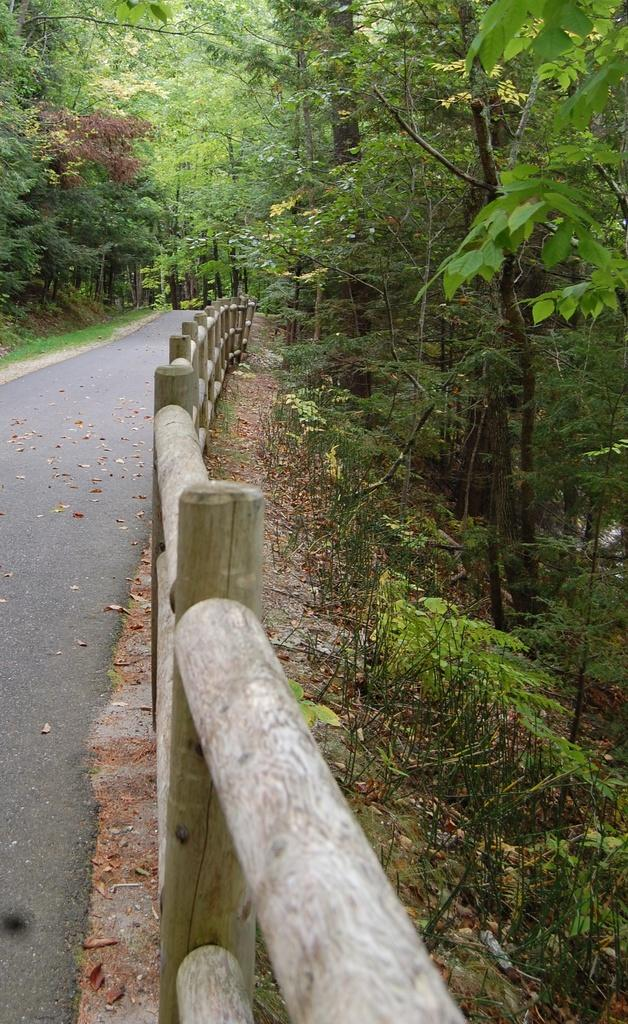What is the main feature of the image? There is a road at the center of the image. What can be seen on the right side of the image? There are trees on the right side of the image. What can be seen on the left side of the image? There are trees on the left side of the image. Can you see a giraffe walking along the road in the image? No, there is no giraffe present in the image. Is there a judge sitting on a drum in the image? No, there is no judge or drum present in the image. 